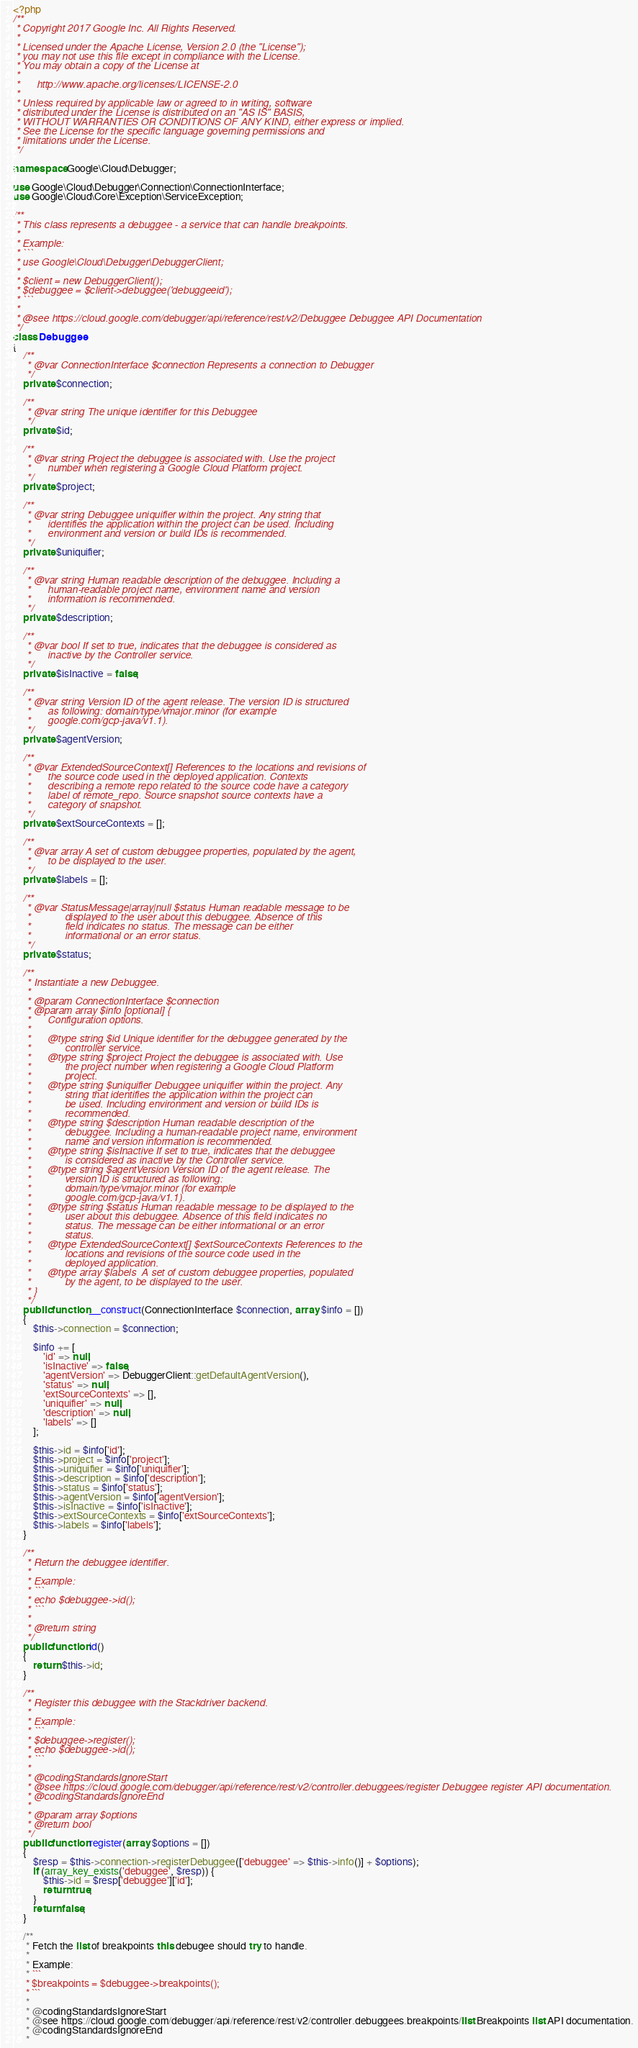Convert code to text. <code><loc_0><loc_0><loc_500><loc_500><_PHP_><?php
/**
 * Copyright 2017 Google Inc. All Rights Reserved.
 *
 * Licensed under the Apache License, Version 2.0 (the "License");
 * you may not use this file except in compliance with the License.
 * You may obtain a copy of the License at
 *
 *      http://www.apache.org/licenses/LICENSE-2.0
 *
 * Unless required by applicable law or agreed to in writing, software
 * distributed under the License is distributed on an "AS IS" BASIS,
 * WITHOUT WARRANTIES OR CONDITIONS OF ANY KIND, either express or implied.
 * See the License for the specific language governing permissions and
 * limitations under the License.
 */

namespace Google\Cloud\Debugger;

use Google\Cloud\Debugger\Connection\ConnectionInterface;
use Google\Cloud\Core\Exception\ServiceException;

/**
 * This class represents a debuggee - a service that can handle breakpoints.
 *
 * Example:
 * ```
 * use Google\Cloud\Debugger\DebuggerClient;
 *
 * $client = new DebuggerClient();
 * $debuggee = $client->debuggee('debuggeeid');
 * ```
 *
 * @see https://cloud.google.com/debugger/api/reference/rest/v2/Debuggee Debuggee API Documentation
 */
class Debuggee
{
    /**
     * @var ConnectionInterface $connection Represents a connection to Debugger
     */
    private $connection;

    /**
     * @var string The unique identifier for this Debuggee
     */
    private $id;

    /**
     * @var string Project the debuggee is associated with. Use the project
     *      number when registering a Google Cloud Platform project.
     */
    private $project;

    /**
     * @var string Debuggee uniquifier within the project. Any string that
     *      identifies the application within the project can be used. Including
     *      environment and version or build IDs is recommended.
     */
    private $uniquifier;

    /**
     * @var string Human readable description of the debuggee. Including a
     *      human-readable project name, environment name and version
     *      information is recommended.
     */
    private $description;

    /**
     * @var bool If set to true, indicates that the debuggee is considered as
     *      inactive by the Controller service.
     */
    private $isInactive = false;

    /**
     * @var string Version ID of the agent release. The version ID is structured
     *      as following: domain/type/vmajor.minor (for example
     *      google.com/gcp-java/v1.1).
     */
    private $agentVersion;

    /**
     * @var ExtendedSourceContext[] References to the locations and revisions of
     *      the source code used in the deployed application. Contexts
     *      describing a remote repo related to the source code have a category
     *      label of remote_repo. Source snapshot source contexts have a
     *      category of snapshot.
     */
    private $extSourceContexts = [];

    /**
     * @var array A set of custom debuggee properties, populated by the agent,
     *      to be displayed to the user.
     */
    private $labels = [];

    /**
     * @var StatusMessage|array|null $status Human readable message to be
     *            displayed to the user about this debuggee. Absence of this
     *            field indicates no status. The message can be either
     *            informational or an error status.
     */
    private $status;

    /**
     * Instantiate a new Debuggee.
     *
     * @param ConnectionInterface $connection
     * @param array $info [optional] {
     *      Configuration options.
     *
     *      @type string $id Unique identifier for the debuggee generated by the
     *            controller service.
     *      @type string $project Project the debuggee is associated with. Use
     *            the project number when registering a Google Cloud Platform
     *            project.
     *      @type string $uniquifier Debuggee uniquifier within the project. Any
     *            string that identifies the application within the project can
     *            be used. Including environment and version or build IDs is
     *            recommended.
     *      @type string $description Human readable description of the
     *            debuggee. Including a human-readable project name, environment
     *            name and version information is recommended.
     *      @type string $isInactive If set to true, indicates that the debuggee
     *            is considered as inactive by the Controller service.
     *      @type string $agentVersion Version ID of the agent release. The
     *            version ID is structured as following:
     *            domain/type/vmajor.minor (for example
     *            google.com/gcp-java/v1.1).
     *      @type string $status Human readable message to be displayed to the
     *            user about this debuggee. Absence of this field indicates no
     *            status. The message can be either informational or an error
     *            status.
     *      @type ExtendedSourceContext[] $extSourceContexts References to the
     *            locations and revisions of the source code used in the
     *            deployed application.
     *      @type array $labels  A set of custom debuggee properties, populated
     *            by the agent, to be displayed to the user.
     * }
     */
    public function __construct(ConnectionInterface $connection, array $info = [])
    {
        $this->connection = $connection;

        $info += [
            'id' => null,
            'isInactive' => false,
            'agentVersion' => DebuggerClient::getDefaultAgentVersion(),
            'status' => null,
            'extSourceContexts' => [],
            'uniquifier' => null,
            'description' => null,
            'labels' => []
        ];

        $this->id = $info['id'];
        $this->project = $info['project'];
        $this->uniquifier = $info['uniquifier'];
        $this->description = $info['description'];
        $this->status = $info['status'];
        $this->agentVersion = $info['agentVersion'];
        $this->isInactive = $info['isInactive'];
        $this->extSourceContexts = $info['extSourceContexts'];
        $this->labels = $info['labels'];
    }

    /**
     * Return the debuggee identifier.
     *
     * Example:
     * ```
     * echo $debuggee->id();
     * ```
     *
     * @return string
     */
    public function id()
    {
        return $this->id;
    }

    /**
     * Register this debuggee with the Stackdriver backend.
     *
     * Example:
     * ```
     * $debuggee->register();
     * echo $debuggee->id();
     * ```
     *
     * @codingStandardsIgnoreStart
     * @see https://cloud.google.com/debugger/api/reference/rest/v2/controller.debuggees/register Debuggee register API documentation.
     * @codingStandardsIgnoreEnd
     *
     * @param array $options
     * @return bool
     */
    public function register(array $options = [])
    {
        $resp = $this->connection->registerDebuggee(['debuggee' => $this->info()] + $options);
        if (array_key_exists('debuggee', $resp)) {
            $this->id = $resp['debuggee']['id'];
            return true;
        }
        return false;
    }

    /**
     * Fetch the list of breakpoints this debugee should try to handle.
     *
     * Example:
     * ```
     * $breakpoints = $debuggee->breakpoints();
     * ```
     *
     * @codingStandardsIgnoreStart
     * @see https://cloud.google.com/debugger/api/reference/rest/v2/controller.debuggees.breakpoints/list Breakpoints list API documentation.
     * @codingStandardsIgnoreEnd
     *</code> 